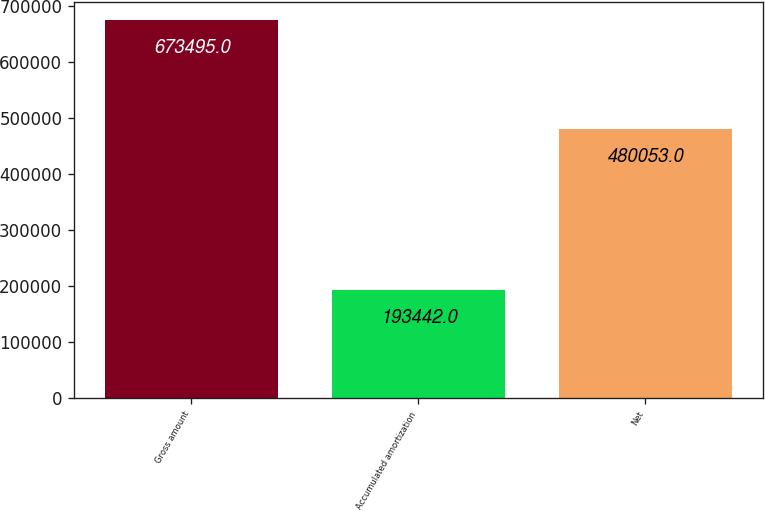<chart> <loc_0><loc_0><loc_500><loc_500><bar_chart><fcel>Gross amount<fcel>Accumulated amortization<fcel>Net<nl><fcel>673495<fcel>193442<fcel>480053<nl></chart> 